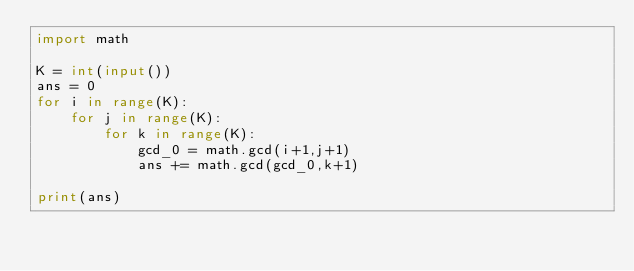Convert code to text. <code><loc_0><loc_0><loc_500><loc_500><_Python_>import math

K = int(input())
ans = 0
for i in range(K):
    for j in range(K):
        for k in range(K):
            gcd_0 = math.gcd(i+1,j+1)
            ans += math.gcd(gcd_0,k+1)

print(ans)</code> 